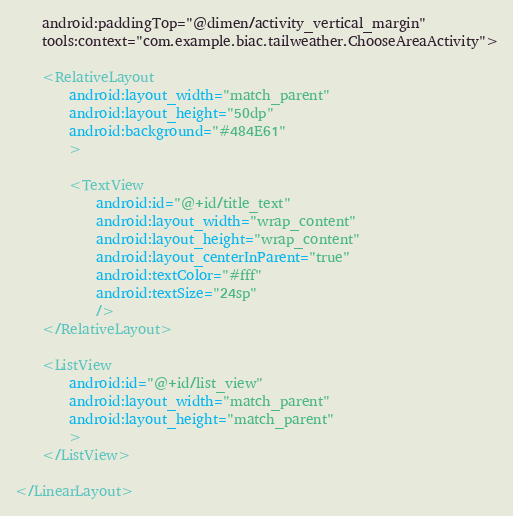<code> <loc_0><loc_0><loc_500><loc_500><_XML_>    android:paddingTop="@dimen/activity_vertical_margin"
    tools:context="com.example.biac.tailweather.ChooseAreaActivity">

    <RelativeLayout
        android:layout_width="match_parent"
        android:layout_height="50dp"
        android:background="#484E61"
        >

        <TextView
            android:id="@+id/title_text"
            android:layout_width="wrap_content"
            android:layout_height="wrap_content"
            android:layout_centerInParent="true"
            android:textColor="#fff"
            android:textSize="24sp"
            />
    </RelativeLayout>

    <ListView
        android:id="@+id/list_view"
        android:layout_width="match_parent"
        android:layout_height="match_parent"
        >
    </ListView>

</LinearLayout>
</code> 